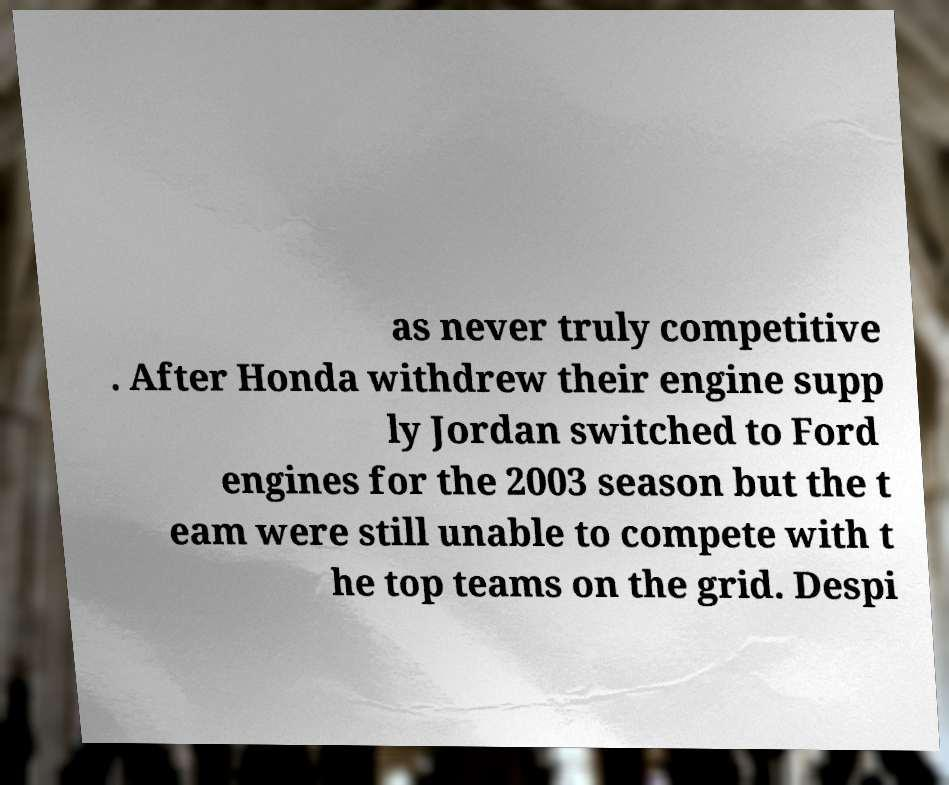I need the written content from this picture converted into text. Can you do that? as never truly competitive . After Honda withdrew their engine supp ly Jordan switched to Ford engines for the 2003 season but the t eam were still unable to compete with t he top teams on the grid. Despi 